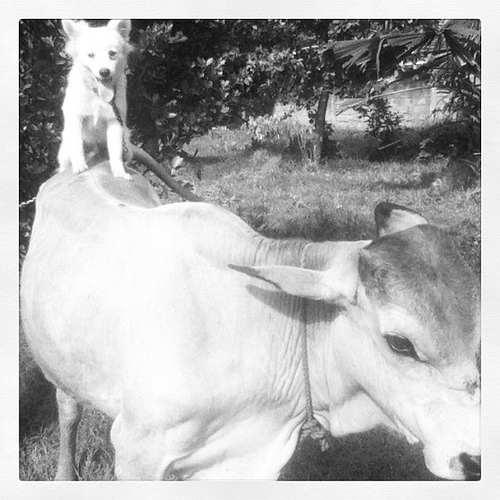Is it common for dogs to interact with cows like this? It's not typical behavior for dogs and cows to interact this closely, but animals can form unique friendships, often surprising us with their social bonds. 